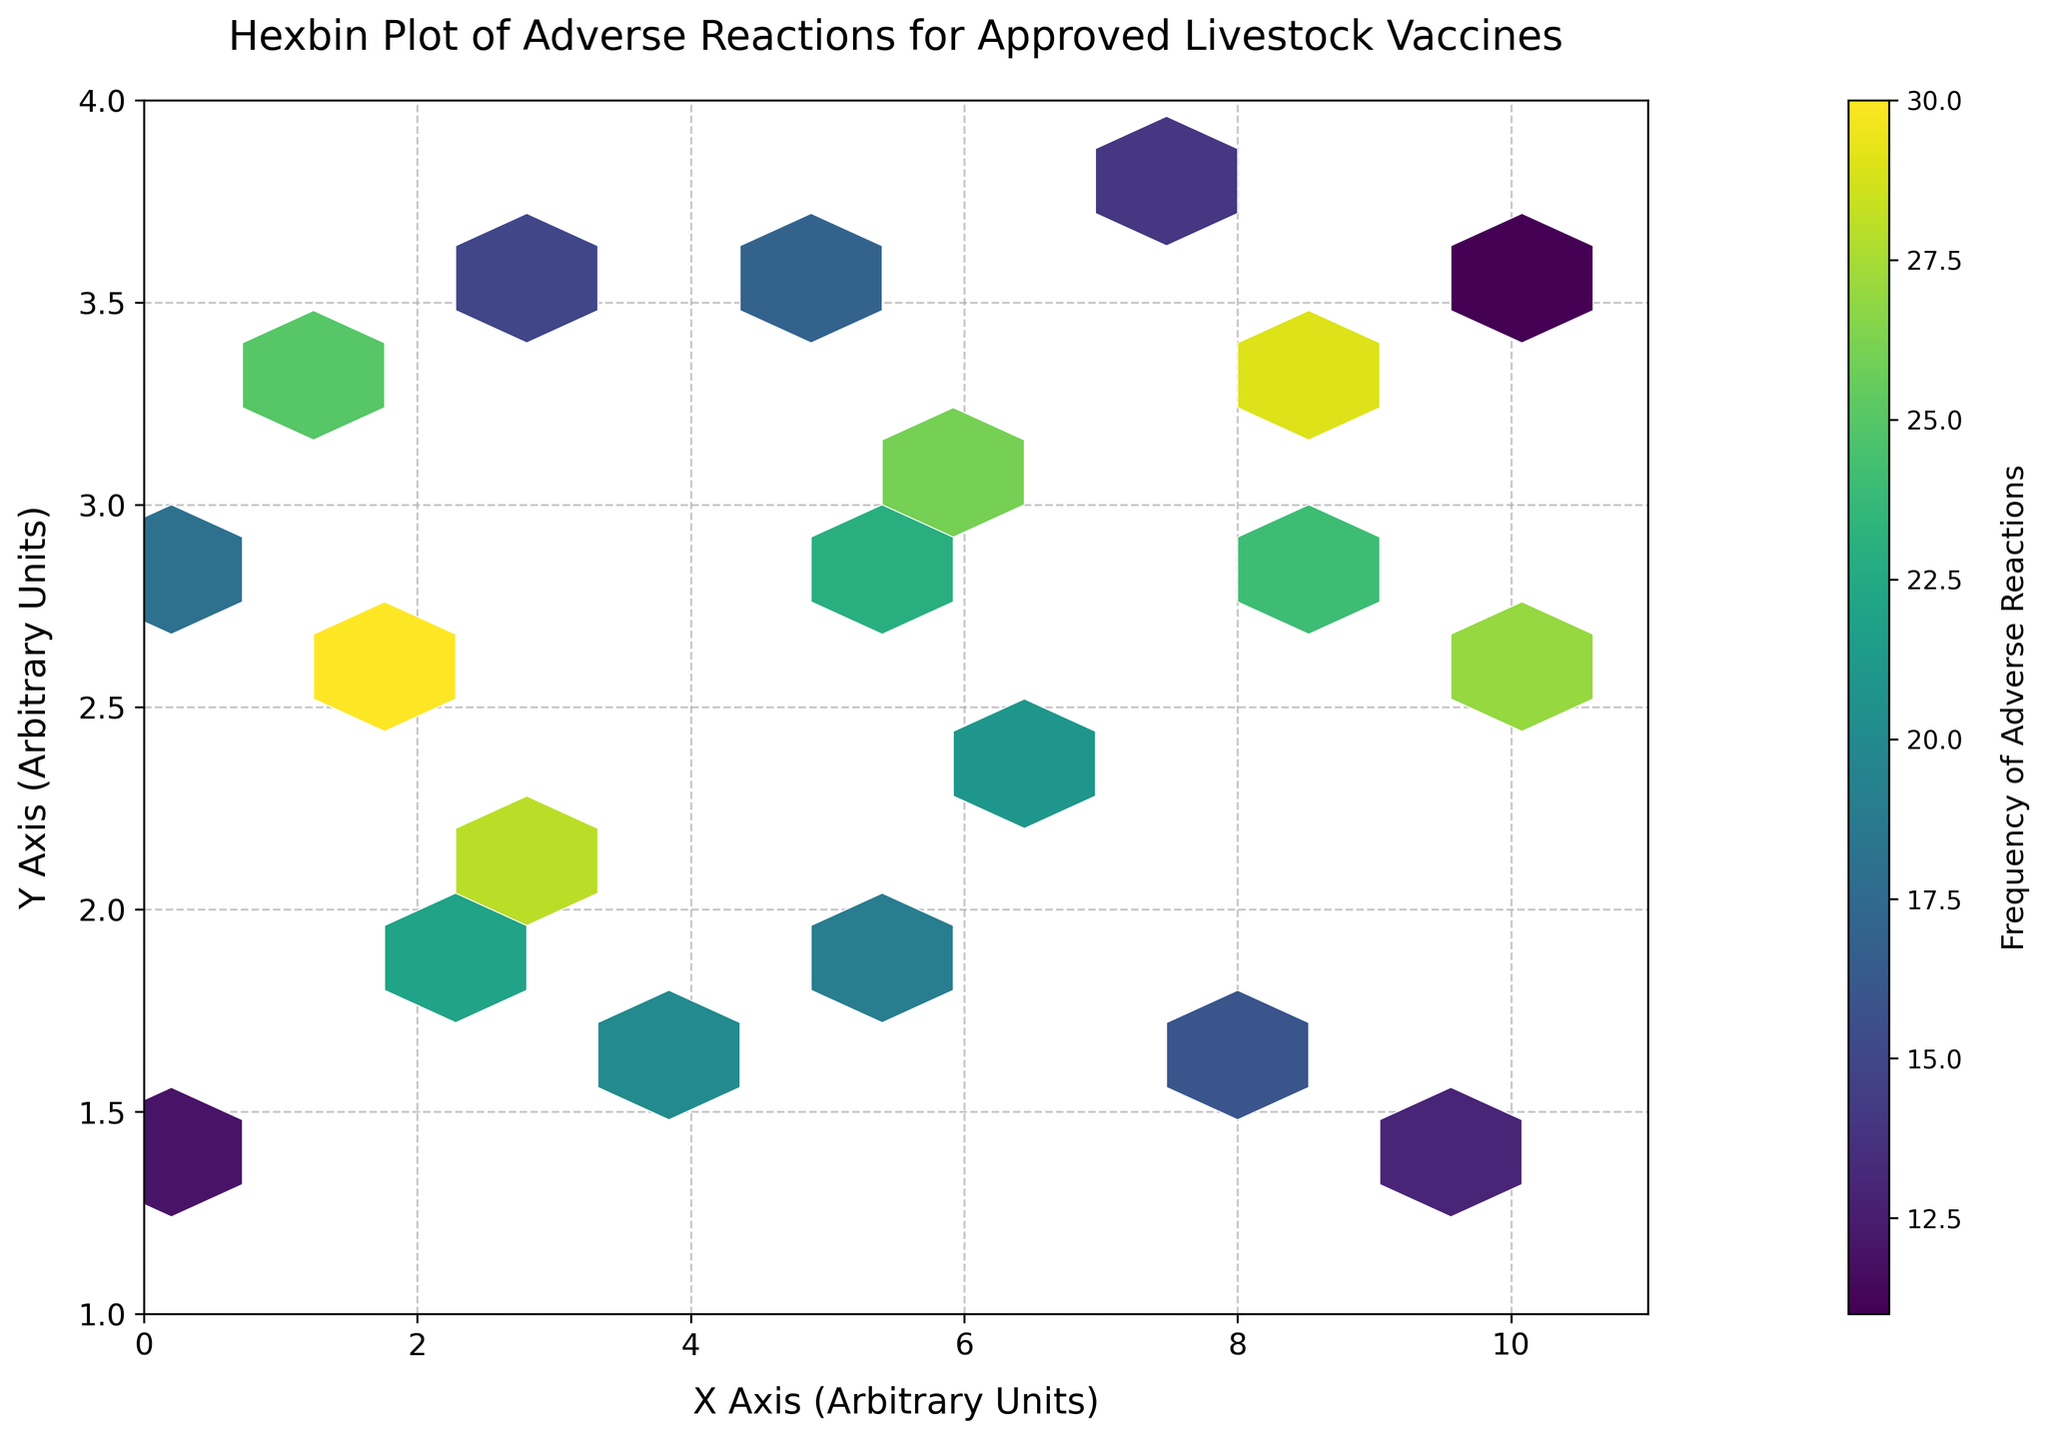What is the title of the figure? The title of a figure is usually prominently displayed at the top and serves as a summary of the plot. The title in this figure is "Hexbin Plot of Adverse Reactions for Approved Livestock Vaccines," which provides an overview of what the plot represents.
Answer: Hexbin Plot of Adverse Reactions for Approved Livestock Vaccines What are the labels of the X and Y axes? The labels for the axes are typically found alongside the respective axes. In this plot, the X-axis label is "X Axis (Arbitrary Units)" and the Y-axis label is "Y Axis (Arbitrary Units)."
Answer: X Axis (Arbitrary Units), Y Axis (Arbitrary Units) What does the color intensity represent in the hexbin plot? In a hexbin plot, color intensity usually indicates a certain value or frequency. According to the color bar, the color intensity here represents the "Frequency of Adverse Reactions," which is indicated on the color bar labeled as such. The color varies from light to dark as the frequency increases.
Answer: Frequency of Adverse Reactions What is the frequency range indicated by the colorbar? The colorbar provides a visual representation of the frequency values through color gradients. The frequency range indicated by the colorbar starts at 11 and goes up to 30, as seen on the colorbar's scale.
Answer: 11 to 30 Which hexagon represents the highest frequency of adverse reactions? To find the hexagon with the highest frequency, look for the hexagon with the darkest color because the color intensity indicates frequency. The highest frequency in this plot is 30, which appears at coordinates approximately (1.8, 2.5).
Answer: at (1.8, 2.5) What is the approximate frequency of adverse reactions at (7.3, 3.8)? Locate the hexagon near (7.3, 3.8) and refer to its color. By comparing it to the colorbar, the frequency for this hexagon is around 14 since it matches a lighter shade on the color scale.
Answer: 14 How do the frequencies compare between the hexagons at (5.1, 2.9) and (0.5, 2.8)? Compare the colors of the hexagons at these two coordinates. The hexagon at (5.1, 2.9) is darker, representing a frequency of 23, while (0.5, 2.8) has a slightly lighter color, representing a frequency of 18. Thus, the frequency at (5.1, 2.9) is higher.
Answer: 23 is higher than 18 Are there any hexagons with the same frequency of adverse reactions? Look at the hexagons with similar colors and refer to the colorbar to check if their frequencies match. Hexagons at (2.3, 1.9) and (6.8, 2.4) both have a frequency of 21, as indicated by their colors.
Answer: Yes, 21 at (2.3, 1.9) and (6.8, 2.4) What range on the X-axis and Y-axis does the plot cover? Examine the X and Y limits set in the plot. The X-axis range is from 0 to 11, and the Y-axis range is from 1 to 4, as delineated by the plot borders.
Answer: X-axis: 0 to 11, Y-axis: 1 to 4 Is there any visible clustering in the plot, and if so, where? Clustering appears where the hexagons are densely populated and often darker in color. There is noticeable clustering around the coordinates (6, 2.5) and (9, 3), which indicates frequent occurrences of similar frequencies.
Answer: Yes, around (6, 2.5) and (9, 3) 